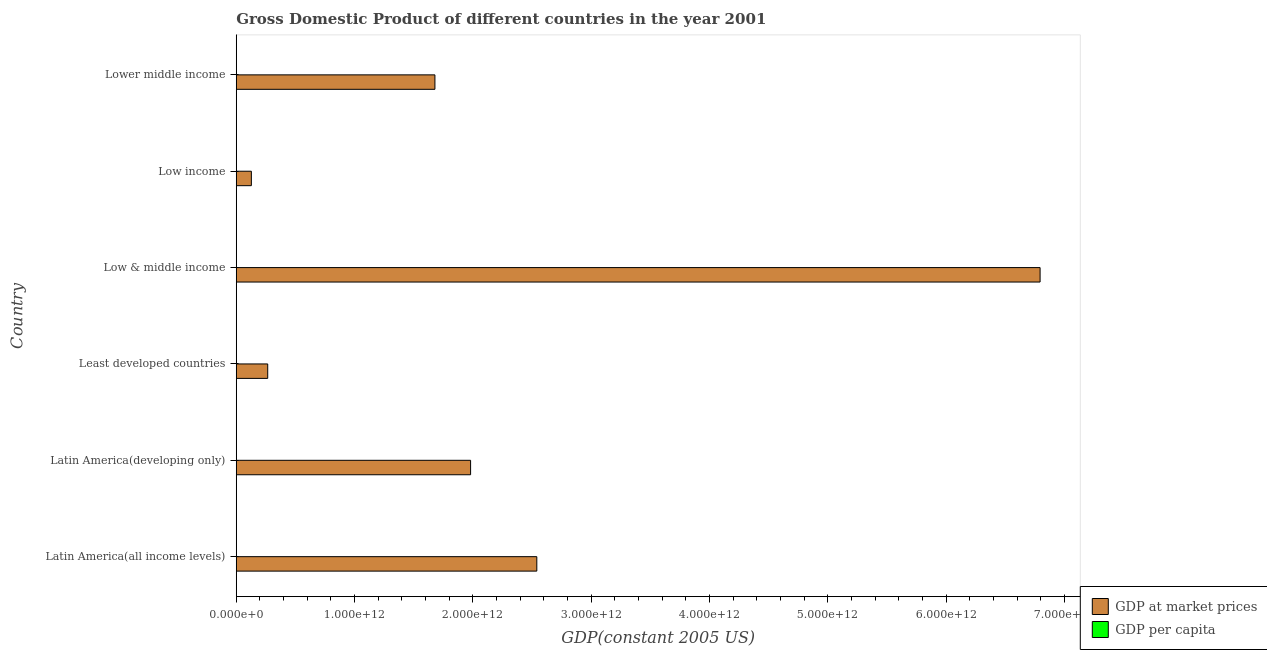Are the number of bars per tick equal to the number of legend labels?
Your response must be concise. Yes. How many bars are there on the 1st tick from the bottom?
Your answer should be very brief. 2. What is the label of the 6th group of bars from the top?
Ensure brevity in your answer.  Latin America(all income levels). In how many cases, is the number of bars for a given country not equal to the number of legend labels?
Make the answer very short. 0. What is the gdp per capita in Lower middle income?
Provide a short and direct response. 716.38. Across all countries, what is the maximum gdp per capita?
Your answer should be compact. 4761.14. Across all countries, what is the minimum gdp per capita?
Give a very brief answer. 291.74. In which country was the gdp per capita maximum?
Make the answer very short. Latin America(all income levels). In which country was the gdp at market prices minimum?
Offer a very short reply. Low income. What is the total gdp per capita in the graph?
Make the answer very short. 1.20e+04. What is the difference between the gdp per capita in Low & middle income and that in Lower middle income?
Offer a terse response. 668.64. What is the difference between the gdp per capita in Latin America(developing only) and the gdp at market prices in Low income?
Offer a terse response. -1.28e+11. What is the average gdp per capita per country?
Provide a short and direct response. 1997.25. What is the difference between the gdp per capita and gdp at market prices in Least developed countries?
Make the answer very short. -2.66e+11. What is the ratio of the gdp per capita in Latin America(all income levels) to that in Low & middle income?
Offer a very short reply. 3.44. Is the gdp per capita in Latin America(all income levels) less than that in Lower middle income?
Your answer should be compact. No. Is the difference between the gdp per capita in Latin America(all income levels) and Least developed countries greater than the difference between the gdp at market prices in Latin America(all income levels) and Least developed countries?
Your response must be concise. No. What is the difference between the highest and the second highest gdp at market prices?
Offer a very short reply. 4.25e+12. What is the difference between the highest and the lowest gdp at market prices?
Keep it short and to the point. 6.67e+12. In how many countries, is the gdp at market prices greater than the average gdp at market prices taken over all countries?
Give a very brief answer. 2. Is the sum of the gdp at market prices in Latin America(developing only) and Lower middle income greater than the maximum gdp per capita across all countries?
Give a very brief answer. Yes. What does the 1st bar from the top in Least developed countries represents?
Give a very brief answer. GDP per capita. What does the 1st bar from the bottom in Low income represents?
Provide a short and direct response. GDP at market prices. How many bars are there?
Give a very brief answer. 12. Are all the bars in the graph horizontal?
Provide a short and direct response. Yes. What is the difference between two consecutive major ticks on the X-axis?
Your response must be concise. 1.00e+12. Are the values on the major ticks of X-axis written in scientific E-notation?
Ensure brevity in your answer.  Yes. Does the graph contain any zero values?
Provide a succinct answer. No. Does the graph contain grids?
Make the answer very short. No. Where does the legend appear in the graph?
Ensure brevity in your answer.  Bottom right. How many legend labels are there?
Your response must be concise. 2. How are the legend labels stacked?
Your answer should be compact. Vertical. What is the title of the graph?
Your answer should be very brief. Gross Domestic Product of different countries in the year 2001. Does "Lowest 20% of population" appear as one of the legend labels in the graph?
Your answer should be compact. No. What is the label or title of the X-axis?
Your answer should be compact. GDP(constant 2005 US). What is the GDP(constant 2005 US) of GDP at market prices in Latin America(all income levels)?
Offer a terse response. 2.54e+12. What is the GDP(constant 2005 US) in GDP per capita in Latin America(all income levels)?
Your response must be concise. 4761.14. What is the GDP(constant 2005 US) in GDP at market prices in Latin America(developing only)?
Ensure brevity in your answer.  1.98e+12. What is the GDP(constant 2005 US) in GDP per capita in Latin America(developing only)?
Give a very brief answer. 4439.03. What is the GDP(constant 2005 US) of GDP at market prices in Least developed countries?
Offer a very short reply. 2.66e+11. What is the GDP(constant 2005 US) in GDP per capita in Least developed countries?
Offer a terse response. 390.19. What is the GDP(constant 2005 US) in GDP at market prices in Low & middle income?
Offer a terse response. 6.79e+12. What is the GDP(constant 2005 US) of GDP per capita in Low & middle income?
Provide a short and direct response. 1385.02. What is the GDP(constant 2005 US) in GDP at market prices in Low income?
Make the answer very short. 1.28e+11. What is the GDP(constant 2005 US) in GDP per capita in Low income?
Give a very brief answer. 291.74. What is the GDP(constant 2005 US) of GDP at market prices in Lower middle income?
Provide a short and direct response. 1.68e+12. What is the GDP(constant 2005 US) of GDP per capita in Lower middle income?
Your answer should be very brief. 716.38. Across all countries, what is the maximum GDP(constant 2005 US) of GDP at market prices?
Your answer should be very brief. 6.79e+12. Across all countries, what is the maximum GDP(constant 2005 US) in GDP per capita?
Give a very brief answer. 4761.14. Across all countries, what is the minimum GDP(constant 2005 US) of GDP at market prices?
Make the answer very short. 1.28e+11. Across all countries, what is the minimum GDP(constant 2005 US) in GDP per capita?
Provide a short and direct response. 291.74. What is the total GDP(constant 2005 US) in GDP at market prices in the graph?
Ensure brevity in your answer.  1.34e+13. What is the total GDP(constant 2005 US) of GDP per capita in the graph?
Make the answer very short. 1.20e+04. What is the difference between the GDP(constant 2005 US) in GDP at market prices in Latin America(all income levels) and that in Latin America(developing only)?
Provide a short and direct response. 5.60e+11. What is the difference between the GDP(constant 2005 US) in GDP per capita in Latin America(all income levels) and that in Latin America(developing only)?
Provide a succinct answer. 322.11. What is the difference between the GDP(constant 2005 US) of GDP at market prices in Latin America(all income levels) and that in Least developed countries?
Keep it short and to the point. 2.27e+12. What is the difference between the GDP(constant 2005 US) in GDP per capita in Latin America(all income levels) and that in Least developed countries?
Provide a short and direct response. 4370.95. What is the difference between the GDP(constant 2005 US) in GDP at market prices in Latin America(all income levels) and that in Low & middle income?
Offer a terse response. -4.25e+12. What is the difference between the GDP(constant 2005 US) of GDP per capita in Latin America(all income levels) and that in Low & middle income?
Ensure brevity in your answer.  3376.12. What is the difference between the GDP(constant 2005 US) of GDP at market prices in Latin America(all income levels) and that in Low income?
Provide a short and direct response. 2.41e+12. What is the difference between the GDP(constant 2005 US) in GDP per capita in Latin America(all income levels) and that in Low income?
Offer a very short reply. 4469.4. What is the difference between the GDP(constant 2005 US) in GDP at market prices in Latin America(all income levels) and that in Lower middle income?
Your response must be concise. 8.61e+11. What is the difference between the GDP(constant 2005 US) in GDP per capita in Latin America(all income levels) and that in Lower middle income?
Give a very brief answer. 4044.76. What is the difference between the GDP(constant 2005 US) of GDP at market prices in Latin America(developing only) and that in Least developed countries?
Ensure brevity in your answer.  1.71e+12. What is the difference between the GDP(constant 2005 US) of GDP per capita in Latin America(developing only) and that in Least developed countries?
Your answer should be very brief. 4048.84. What is the difference between the GDP(constant 2005 US) of GDP at market prices in Latin America(developing only) and that in Low & middle income?
Your answer should be compact. -4.81e+12. What is the difference between the GDP(constant 2005 US) in GDP per capita in Latin America(developing only) and that in Low & middle income?
Make the answer very short. 3054.01. What is the difference between the GDP(constant 2005 US) of GDP at market prices in Latin America(developing only) and that in Low income?
Provide a succinct answer. 1.85e+12. What is the difference between the GDP(constant 2005 US) of GDP per capita in Latin America(developing only) and that in Low income?
Provide a short and direct response. 4147.28. What is the difference between the GDP(constant 2005 US) of GDP at market prices in Latin America(developing only) and that in Lower middle income?
Make the answer very short. 3.01e+11. What is the difference between the GDP(constant 2005 US) in GDP per capita in Latin America(developing only) and that in Lower middle income?
Make the answer very short. 3722.65. What is the difference between the GDP(constant 2005 US) of GDP at market prices in Least developed countries and that in Low & middle income?
Make the answer very short. -6.53e+12. What is the difference between the GDP(constant 2005 US) in GDP per capita in Least developed countries and that in Low & middle income?
Your answer should be very brief. -994.83. What is the difference between the GDP(constant 2005 US) in GDP at market prices in Least developed countries and that in Low income?
Provide a short and direct response. 1.38e+11. What is the difference between the GDP(constant 2005 US) of GDP per capita in Least developed countries and that in Low income?
Offer a very short reply. 98.45. What is the difference between the GDP(constant 2005 US) of GDP at market prices in Least developed countries and that in Lower middle income?
Ensure brevity in your answer.  -1.41e+12. What is the difference between the GDP(constant 2005 US) of GDP per capita in Least developed countries and that in Lower middle income?
Ensure brevity in your answer.  -326.19. What is the difference between the GDP(constant 2005 US) of GDP at market prices in Low & middle income and that in Low income?
Give a very brief answer. 6.67e+12. What is the difference between the GDP(constant 2005 US) in GDP per capita in Low & middle income and that in Low income?
Your answer should be very brief. 1093.28. What is the difference between the GDP(constant 2005 US) in GDP at market prices in Low & middle income and that in Lower middle income?
Offer a terse response. 5.11e+12. What is the difference between the GDP(constant 2005 US) of GDP per capita in Low & middle income and that in Lower middle income?
Offer a very short reply. 668.64. What is the difference between the GDP(constant 2005 US) in GDP at market prices in Low income and that in Lower middle income?
Offer a terse response. -1.55e+12. What is the difference between the GDP(constant 2005 US) of GDP per capita in Low income and that in Lower middle income?
Offer a terse response. -424.64. What is the difference between the GDP(constant 2005 US) of GDP at market prices in Latin America(all income levels) and the GDP(constant 2005 US) of GDP per capita in Latin America(developing only)?
Ensure brevity in your answer.  2.54e+12. What is the difference between the GDP(constant 2005 US) of GDP at market prices in Latin America(all income levels) and the GDP(constant 2005 US) of GDP per capita in Least developed countries?
Offer a very short reply. 2.54e+12. What is the difference between the GDP(constant 2005 US) of GDP at market prices in Latin America(all income levels) and the GDP(constant 2005 US) of GDP per capita in Low & middle income?
Your answer should be compact. 2.54e+12. What is the difference between the GDP(constant 2005 US) in GDP at market prices in Latin America(all income levels) and the GDP(constant 2005 US) in GDP per capita in Low income?
Ensure brevity in your answer.  2.54e+12. What is the difference between the GDP(constant 2005 US) in GDP at market prices in Latin America(all income levels) and the GDP(constant 2005 US) in GDP per capita in Lower middle income?
Your response must be concise. 2.54e+12. What is the difference between the GDP(constant 2005 US) of GDP at market prices in Latin America(developing only) and the GDP(constant 2005 US) of GDP per capita in Least developed countries?
Ensure brevity in your answer.  1.98e+12. What is the difference between the GDP(constant 2005 US) in GDP at market prices in Latin America(developing only) and the GDP(constant 2005 US) in GDP per capita in Low & middle income?
Offer a very short reply. 1.98e+12. What is the difference between the GDP(constant 2005 US) of GDP at market prices in Latin America(developing only) and the GDP(constant 2005 US) of GDP per capita in Low income?
Your response must be concise. 1.98e+12. What is the difference between the GDP(constant 2005 US) of GDP at market prices in Latin America(developing only) and the GDP(constant 2005 US) of GDP per capita in Lower middle income?
Your answer should be very brief. 1.98e+12. What is the difference between the GDP(constant 2005 US) in GDP at market prices in Least developed countries and the GDP(constant 2005 US) in GDP per capita in Low & middle income?
Ensure brevity in your answer.  2.66e+11. What is the difference between the GDP(constant 2005 US) of GDP at market prices in Least developed countries and the GDP(constant 2005 US) of GDP per capita in Low income?
Your answer should be very brief. 2.66e+11. What is the difference between the GDP(constant 2005 US) in GDP at market prices in Least developed countries and the GDP(constant 2005 US) in GDP per capita in Lower middle income?
Give a very brief answer. 2.66e+11. What is the difference between the GDP(constant 2005 US) of GDP at market prices in Low & middle income and the GDP(constant 2005 US) of GDP per capita in Low income?
Offer a terse response. 6.79e+12. What is the difference between the GDP(constant 2005 US) in GDP at market prices in Low & middle income and the GDP(constant 2005 US) in GDP per capita in Lower middle income?
Keep it short and to the point. 6.79e+12. What is the difference between the GDP(constant 2005 US) of GDP at market prices in Low income and the GDP(constant 2005 US) of GDP per capita in Lower middle income?
Provide a short and direct response. 1.28e+11. What is the average GDP(constant 2005 US) of GDP at market prices per country?
Provide a succinct answer. 2.23e+12. What is the average GDP(constant 2005 US) of GDP per capita per country?
Ensure brevity in your answer.  1997.25. What is the difference between the GDP(constant 2005 US) of GDP at market prices and GDP(constant 2005 US) of GDP per capita in Latin America(all income levels)?
Keep it short and to the point. 2.54e+12. What is the difference between the GDP(constant 2005 US) in GDP at market prices and GDP(constant 2005 US) in GDP per capita in Latin America(developing only)?
Offer a terse response. 1.98e+12. What is the difference between the GDP(constant 2005 US) of GDP at market prices and GDP(constant 2005 US) of GDP per capita in Least developed countries?
Keep it short and to the point. 2.66e+11. What is the difference between the GDP(constant 2005 US) in GDP at market prices and GDP(constant 2005 US) in GDP per capita in Low & middle income?
Your response must be concise. 6.79e+12. What is the difference between the GDP(constant 2005 US) in GDP at market prices and GDP(constant 2005 US) in GDP per capita in Low income?
Ensure brevity in your answer.  1.28e+11. What is the difference between the GDP(constant 2005 US) in GDP at market prices and GDP(constant 2005 US) in GDP per capita in Lower middle income?
Give a very brief answer. 1.68e+12. What is the ratio of the GDP(constant 2005 US) of GDP at market prices in Latin America(all income levels) to that in Latin America(developing only)?
Your response must be concise. 1.28. What is the ratio of the GDP(constant 2005 US) of GDP per capita in Latin America(all income levels) to that in Latin America(developing only)?
Your answer should be very brief. 1.07. What is the ratio of the GDP(constant 2005 US) in GDP at market prices in Latin America(all income levels) to that in Least developed countries?
Offer a terse response. 9.55. What is the ratio of the GDP(constant 2005 US) in GDP per capita in Latin America(all income levels) to that in Least developed countries?
Ensure brevity in your answer.  12.2. What is the ratio of the GDP(constant 2005 US) of GDP at market prices in Latin America(all income levels) to that in Low & middle income?
Make the answer very short. 0.37. What is the ratio of the GDP(constant 2005 US) of GDP per capita in Latin America(all income levels) to that in Low & middle income?
Keep it short and to the point. 3.44. What is the ratio of the GDP(constant 2005 US) in GDP at market prices in Latin America(all income levels) to that in Low income?
Provide a succinct answer. 19.89. What is the ratio of the GDP(constant 2005 US) of GDP per capita in Latin America(all income levels) to that in Low income?
Your answer should be very brief. 16.32. What is the ratio of the GDP(constant 2005 US) in GDP at market prices in Latin America(all income levels) to that in Lower middle income?
Ensure brevity in your answer.  1.51. What is the ratio of the GDP(constant 2005 US) in GDP per capita in Latin America(all income levels) to that in Lower middle income?
Provide a short and direct response. 6.65. What is the ratio of the GDP(constant 2005 US) of GDP at market prices in Latin America(developing only) to that in Least developed countries?
Keep it short and to the point. 7.45. What is the ratio of the GDP(constant 2005 US) of GDP per capita in Latin America(developing only) to that in Least developed countries?
Provide a succinct answer. 11.38. What is the ratio of the GDP(constant 2005 US) of GDP at market prices in Latin America(developing only) to that in Low & middle income?
Keep it short and to the point. 0.29. What is the ratio of the GDP(constant 2005 US) of GDP per capita in Latin America(developing only) to that in Low & middle income?
Your response must be concise. 3.21. What is the ratio of the GDP(constant 2005 US) of GDP at market prices in Latin America(developing only) to that in Low income?
Provide a succinct answer. 15.51. What is the ratio of the GDP(constant 2005 US) in GDP per capita in Latin America(developing only) to that in Low income?
Keep it short and to the point. 15.22. What is the ratio of the GDP(constant 2005 US) in GDP at market prices in Latin America(developing only) to that in Lower middle income?
Your answer should be very brief. 1.18. What is the ratio of the GDP(constant 2005 US) in GDP per capita in Latin America(developing only) to that in Lower middle income?
Offer a terse response. 6.2. What is the ratio of the GDP(constant 2005 US) of GDP at market prices in Least developed countries to that in Low & middle income?
Your answer should be compact. 0.04. What is the ratio of the GDP(constant 2005 US) in GDP per capita in Least developed countries to that in Low & middle income?
Offer a terse response. 0.28. What is the ratio of the GDP(constant 2005 US) of GDP at market prices in Least developed countries to that in Low income?
Offer a very short reply. 2.08. What is the ratio of the GDP(constant 2005 US) of GDP per capita in Least developed countries to that in Low income?
Provide a succinct answer. 1.34. What is the ratio of the GDP(constant 2005 US) in GDP at market prices in Least developed countries to that in Lower middle income?
Ensure brevity in your answer.  0.16. What is the ratio of the GDP(constant 2005 US) of GDP per capita in Least developed countries to that in Lower middle income?
Your answer should be compact. 0.54. What is the ratio of the GDP(constant 2005 US) in GDP at market prices in Low & middle income to that in Low income?
Offer a very short reply. 53.19. What is the ratio of the GDP(constant 2005 US) of GDP per capita in Low & middle income to that in Low income?
Provide a succinct answer. 4.75. What is the ratio of the GDP(constant 2005 US) in GDP at market prices in Low & middle income to that in Lower middle income?
Your answer should be compact. 4.05. What is the ratio of the GDP(constant 2005 US) of GDP per capita in Low & middle income to that in Lower middle income?
Keep it short and to the point. 1.93. What is the ratio of the GDP(constant 2005 US) of GDP at market prices in Low income to that in Lower middle income?
Ensure brevity in your answer.  0.08. What is the ratio of the GDP(constant 2005 US) of GDP per capita in Low income to that in Lower middle income?
Your answer should be compact. 0.41. What is the difference between the highest and the second highest GDP(constant 2005 US) in GDP at market prices?
Ensure brevity in your answer.  4.25e+12. What is the difference between the highest and the second highest GDP(constant 2005 US) in GDP per capita?
Ensure brevity in your answer.  322.11. What is the difference between the highest and the lowest GDP(constant 2005 US) in GDP at market prices?
Make the answer very short. 6.67e+12. What is the difference between the highest and the lowest GDP(constant 2005 US) in GDP per capita?
Your answer should be very brief. 4469.4. 